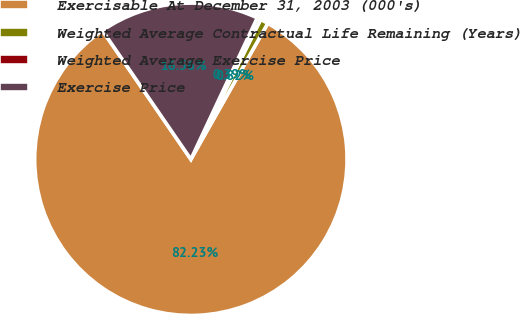Convert chart. <chart><loc_0><loc_0><loc_500><loc_500><pie_chart><fcel>Exercisable At December 31, 2003 (000's)<fcel>Weighted Average Contractual Life Remaining (Years)<fcel>Weighted Average Exercise Price<fcel>Exercise Price<nl><fcel>82.23%<fcel>0.82%<fcel>0.39%<fcel>16.56%<nl></chart> 